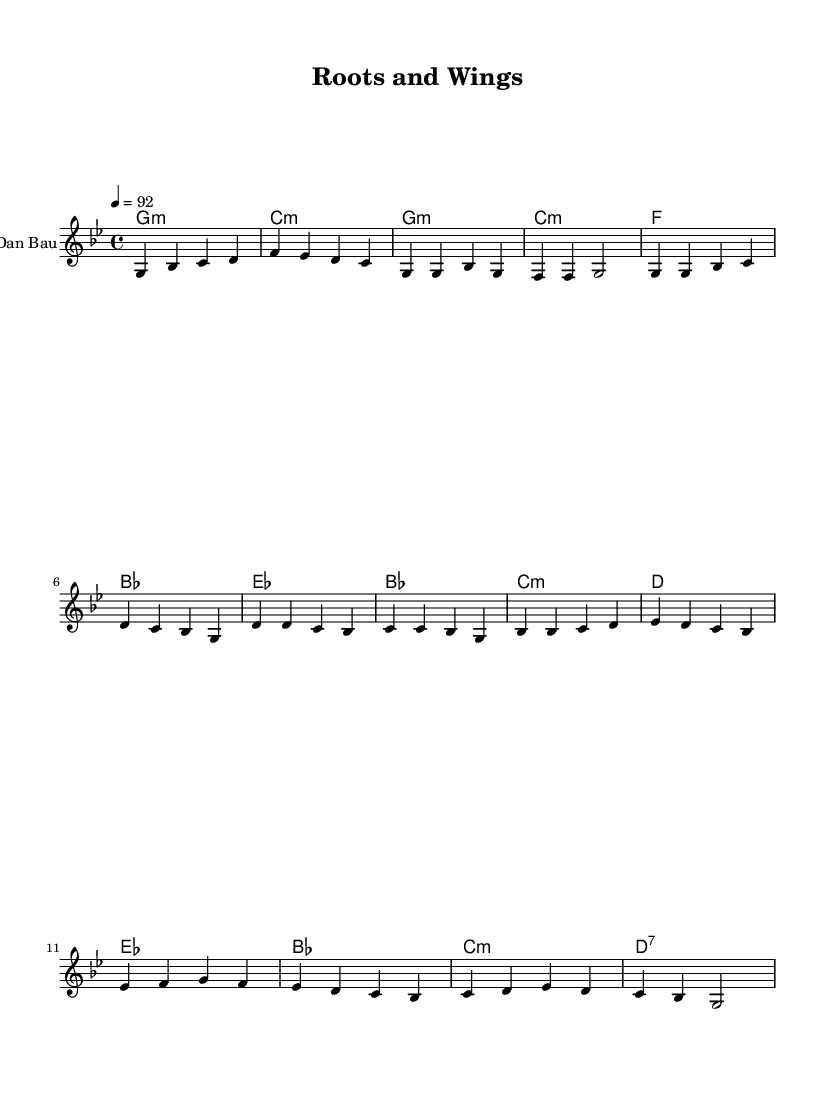What is the key signature of this music? The key signature is indicated by the 'g' that appears at the beginning of the music sheet. The 'g' shows that it is in the key of G minor, which has two flats.
Answer: G minor What is the time signature of this music? The time signature is displayed in the beginning of the music, indicated by the '4/4' that follows the key signature. This shows that there are four beats in a measure, and each beat is a quarter note.
Answer: 4/4 What is the tempo marking of this music? The tempo is indicated by '4 = 92' at the beginning of the score, which means there are 92 beats per minute when counting quarter notes.
Answer: 92 How many measures are there in the verse section? By counting the measures within the 'Verse' section of the music, which is clearly labeled, there are a total of four measures present.
Answer: 4 What chord is played during the chorus? The chords are given in a chord chart above the staff. In the chorus section, the first chord listed is 'es', which corresponds to the key of E flat.
Answer: es What is the last note of the bridge section? The last note of the 'Bridge' section can be found in the little musical symbols, and it is a G note that occurs before the double bar line at the end of this section.
Answer: g Which instrument is indicated for this sheet music? The instrument is specified in the score section, labeled as 'Dan Bau,' which is a traditional Vietnamese string instrument.
Answer: Dan Bau 